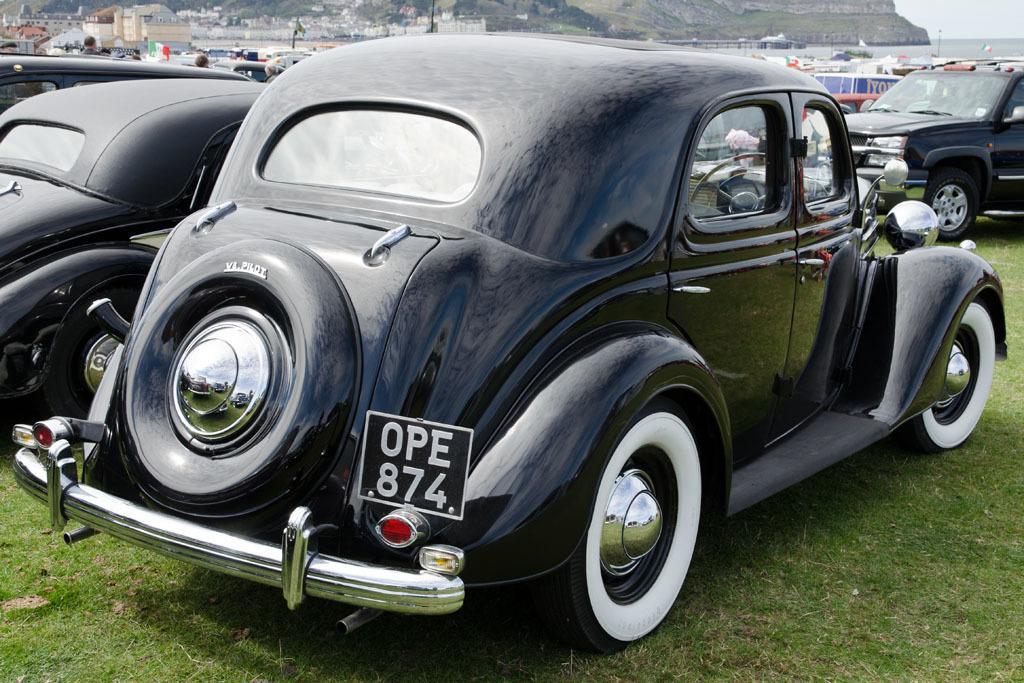Describe this image in one or two sentences. In this image we can see a sea and few hills. There are many vehicles in the image. There is a grassy land in the image. There are few people in the image. There is a sky in the image. There are many houses in the image. 